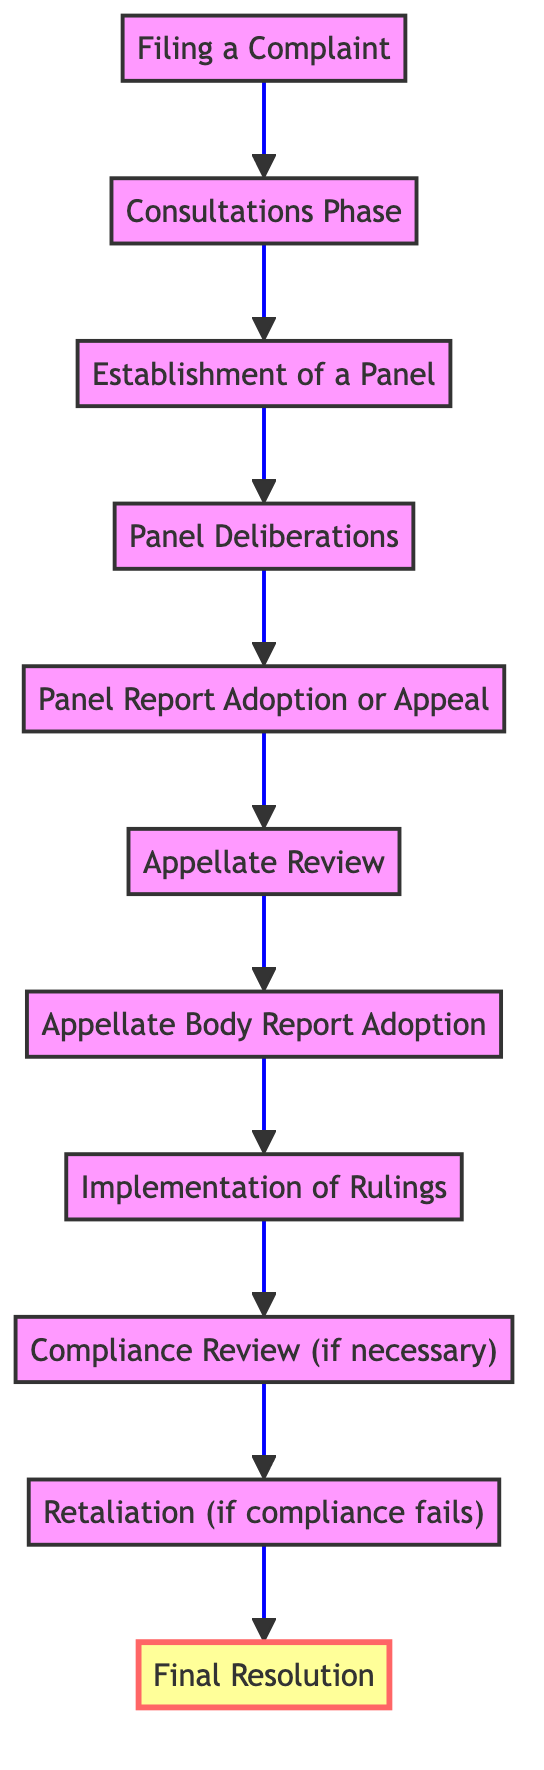What is the first step in the trade dispute resolution process? The first step is "Filing a Complaint," as indicated at the bottom of the flow chart. It initiates the dispute by submitting a complaint to the Dispute Settlement Body (DSB).
Answer: Filing a Complaint How many phases are there before the final resolution? Counting the phases from "Filing a Complaint" to "Final Resolution," there are a total of ten nodes (phases) depicted in the flow chart.
Answer: Ten What occurs if the "Consultations Phase" fails? If the "Consultations Phase" fails, the next step is the "Establishment of a Panel," which involves creating a panel to investigate further.
Answer: Establishment of a Panel What is the maximum time frame for the Appellate Review? The Appellate Review must be completed within 90 days, according to the description in the flowchart.
Answer: 90 days How does the process move from "Implementation of Rulings" to "Final Resolution"? After "Implementation of Rulings," if compliance is disputed, the process may lead to a "Compliance Review." If compliance fails, it leads to "Retaliation" before reaching "Final Resolution."
Answer: Compliance Review What happens if there is an appeal after the Panel Report is generated? If there is an appeal within 60 days of the panel report, the process moves to "Appellate Review," where the WTO Appellate Body examines the case.
Answer: Appellate Review In what situation can trade sanctions be imposed? Trade sanctions may be imposed if the losing party fails to comply, and the prevailing party requests authorization from the DSB.
Answer: Retaliation What is required from the losing party after a ruling is implemented? The losing party must inform the DSB of its plans to implement the ruling; if immediate compliance isn't possible, they are given a reasonable period.
Answer: Implementation of Rulings How many days are allowed for the DSB to adopt the Appellate Body's report? The DSB is required to adopt the Appellate Body's report within 30 days unless there is a consensus opposing it.
Answer: 30 days 